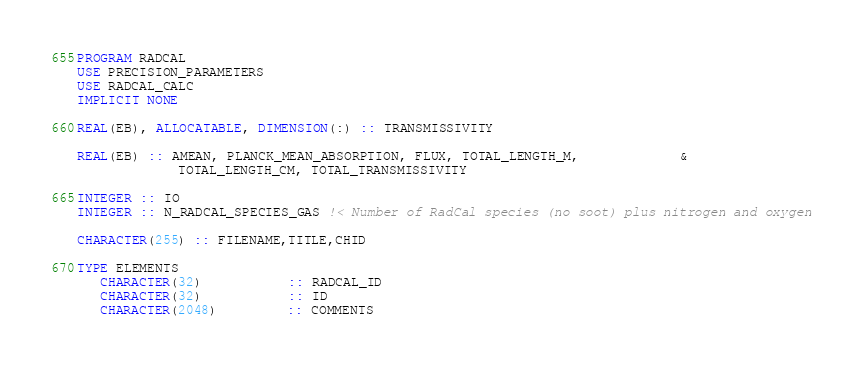Convert code to text. <code><loc_0><loc_0><loc_500><loc_500><_FORTRAN_>PROGRAM RADCAL
USE PRECISION_PARAMETERS
USE RADCAL_CALC
IMPLICIT NONE

REAL(EB), ALLOCATABLE, DIMENSION(:) :: TRANSMISSIVITY

REAL(EB) :: AMEAN, PLANCK_MEAN_ABSORPTION, FLUX, TOTAL_LENGTH_M,             &
             TOTAL_LENGTH_CM, TOTAL_TRANSMISSIVITY

INTEGER :: IO
INTEGER :: N_RADCAL_SPECIES_GAS !< Number of RadCal species (no soot) plus nitrogen and oxygen

CHARACTER(255) :: FILENAME,TITLE,CHID

TYPE ELEMENTS
   CHARACTER(32)           :: RADCAL_ID
   CHARACTER(32)           :: ID
   CHARACTER(2048)         :: COMMENTS</code> 